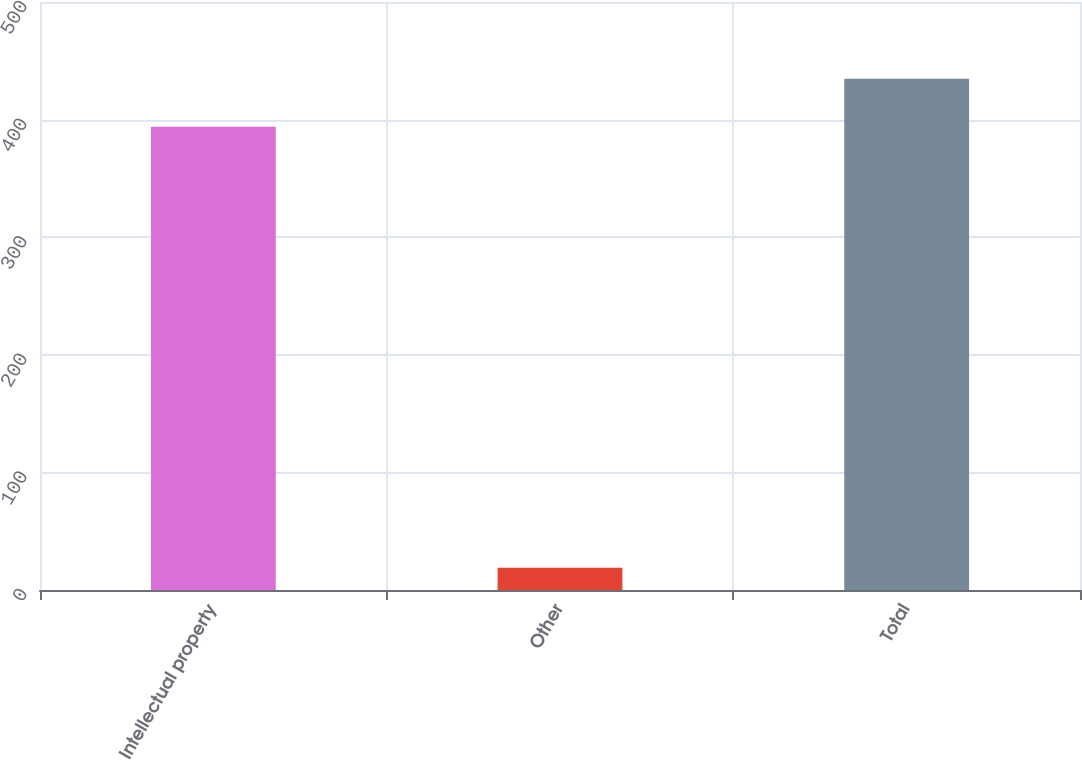Convert chart to OTSL. <chart><loc_0><loc_0><loc_500><loc_500><bar_chart><fcel>Intellectual property<fcel>Other<fcel>Total<nl><fcel>394<fcel>19<fcel>434.7<nl></chart> 